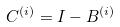Convert formula to latex. <formula><loc_0><loc_0><loc_500><loc_500>C ^ { ( i ) } = I - B ^ { ( i ) }</formula> 